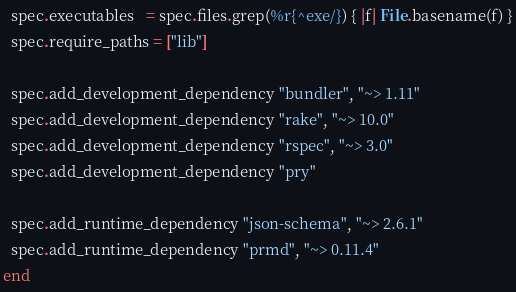<code> <loc_0><loc_0><loc_500><loc_500><_Ruby_>  spec.executables   = spec.files.grep(%r{^exe/}) { |f| File.basename(f) }
  spec.require_paths = ["lib"]

  spec.add_development_dependency "bundler", "~> 1.11"
  spec.add_development_dependency "rake", "~> 10.0"
  spec.add_development_dependency "rspec", "~> 3.0"
  spec.add_development_dependency "pry"

  spec.add_runtime_dependency "json-schema", "~> 2.6.1"
  spec.add_runtime_dependency "prmd", "~> 0.11.4"
end
</code> 